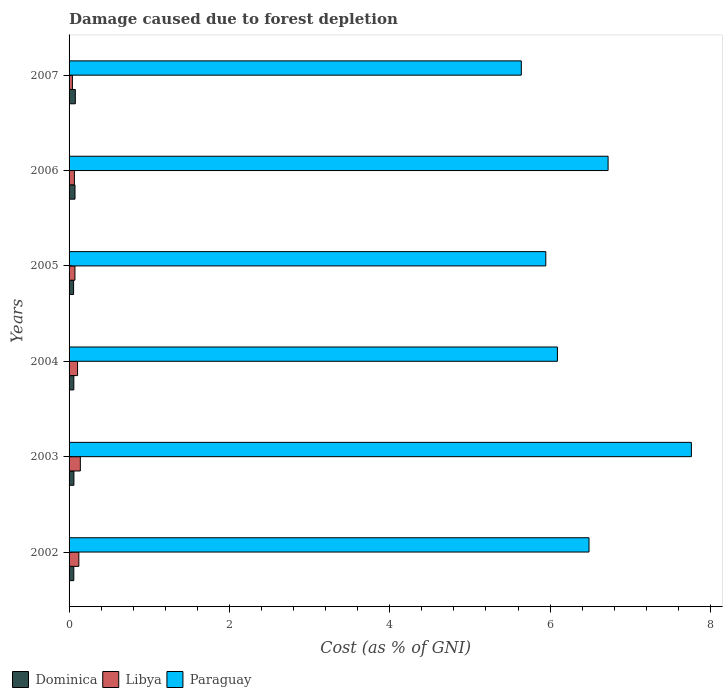How many different coloured bars are there?
Keep it short and to the point. 3. Are the number of bars on each tick of the Y-axis equal?
Ensure brevity in your answer.  Yes. What is the label of the 2nd group of bars from the top?
Give a very brief answer. 2006. In how many cases, is the number of bars for a given year not equal to the number of legend labels?
Your answer should be compact. 0. What is the cost of damage caused due to forest depletion in Paraguay in 2003?
Your answer should be very brief. 7.76. Across all years, what is the maximum cost of damage caused due to forest depletion in Paraguay?
Your answer should be compact. 7.76. Across all years, what is the minimum cost of damage caused due to forest depletion in Paraguay?
Your answer should be very brief. 5.64. In which year was the cost of damage caused due to forest depletion in Paraguay maximum?
Give a very brief answer. 2003. What is the total cost of damage caused due to forest depletion in Libya in the graph?
Provide a succinct answer. 0.55. What is the difference between the cost of damage caused due to forest depletion in Dominica in 2004 and that in 2007?
Offer a very short reply. -0.02. What is the difference between the cost of damage caused due to forest depletion in Libya in 2004 and the cost of damage caused due to forest depletion in Paraguay in 2006?
Provide a succinct answer. -6.62. What is the average cost of damage caused due to forest depletion in Dominica per year?
Your answer should be very brief. 0.06. In the year 2002, what is the difference between the cost of damage caused due to forest depletion in Libya and cost of damage caused due to forest depletion in Dominica?
Provide a succinct answer. 0.06. What is the ratio of the cost of damage caused due to forest depletion in Dominica in 2002 to that in 2004?
Offer a very short reply. 0.99. What is the difference between the highest and the second highest cost of damage caused due to forest depletion in Paraguay?
Give a very brief answer. 1.04. What is the difference between the highest and the lowest cost of damage caused due to forest depletion in Paraguay?
Offer a terse response. 2.12. In how many years, is the cost of damage caused due to forest depletion in Paraguay greater than the average cost of damage caused due to forest depletion in Paraguay taken over all years?
Make the answer very short. 3. Is the sum of the cost of damage caused due to forest depletion in Paraguay in 2002 and 2004 greater than the maximum cost of damage caused due to forest depletion in Dominica across all years?
Your answer should be compact. Yes. What does the 2nd bar from the top in 2003 represents?
Your answer should be compact. Libya. What does the 2nd bar from the bottom in 2002 represents?
Your response must be concise. Libya. How many bars are there?
Your response must be concise. 18. Are all the bars in the graph horizontal?
Make the answer very short. Yes. Are the values on the major ticks of X-axis written in scientific E-notation?
Give a very brief answer. No. Does the graph contain any zero values?
Provide a short and direct response. No. Does the graph contain grids?
Your answer should be very brief. No. Where does the legend appear in the graph?
Your answer should be compact. Bottom left. How many legend labels are there?
Offer a very short reply. 3. How are the legend labels stacked?
Your response must be concise. Horizontal. What is the title of the graph?
Your answer should be very brief. Damage caused due to forest depletion. Does "United Kingdom" appear as one of the legend labels in the graph?
Make the answer very short. No. What is the label or title of the X-axis?
Give a very brief answer. Cost (as % of GNI). What is the label or title of the Y-axis?
Your response must be concise. Years. What is the Cost (as % of GNI) in Dominica in 2002?
Make the answer very short. 0.06. What is the Cost (as % of GNI) in Libya in 2002?
Your response must be concise. 0.12. What is the Cost (as % of GNI) of Paraguay in 2002?
Your response must be concise. 6.49. What is the Cost (as % of GNI) in Dominica in 2003?
Offer a very short reply. 0.06. What is the Cost (as % of GNI) in Libya in 2003?
Offer a terse response. 0.14. What is the Cost (as % of GNI) of Paraguay in 2003?
Your response must be concise. 7.76. What is the Cost (as % of GNI) of Dominica in 2004?
Provide a succinct answer. 0.06. What is the Cost (as % of GNI) of Libya in 2004?
Provide a short and direct response. 0.11. What is the Cost (as % of GNI) of Paraguay in 2004?
Provide a succinct answer. 6.09. What is the Cost (as % of GNI) in Dominica in 2005?
Offer a terse response. 0.06. What is the Cost (as % of GNI) in Libya in 2005?
Provide a short and direct response. 0.07. What is the Cost (as % of GNI) of Paraguay in 2005?
Make the answer very short. 5.95. What is the Cost (as % of GNI) in Dominica in 2006?
Offer a very short reply. 0.07. What is the Cost (as % of GNI) of Libya in 2006?
Ensure brevity in your answer.  0.07. What is the Cost (as % of GNI) in Paraguay in 2006?
Your answer should be compact. 6.72. What is the Cost (as % of GNI) in Dominica in 2007?
Make the answer very short. 0.08. What is the Cost (as % of GNI) of Libya in 2007?
Offer a terse response. 0.04. What is the Cost (as % of GNI) of Paraguay in 2007?
Provide a succinct answer. 5.64. Across all years, what is the maximum Cost (as % of GNI) in Dominica?
Give a very brief answer. 0.08. Across all years, what is the maximum Cost (as % of GNI) in Libya?
Your response must be concise. 0.14. Across all years, what is the maximum Cost (as % of GNI) in Paraguay?
Give a very brief answer. 7.76. Across all years, what is the minimum Cost (as % of GNI) in Dominica?
Provide a short and direct response. 0.06. Across all years, what is the minimum Cost (as % of GNI) in Libya?
Your response must be concise. 0.04. Across all years, what is the minimum Cost (as % of GNI) in Paraguay?
Provide a succinct answer. 5.64. What is the total Cost (as % of GNI) in Dominica in the graph?
Keep it short and to the point. 0.39. What is the total Cost (as % of GNI) in Libya in the graph?
Ensure brevity in your answer.  0.55. What is the total Cost (as % of GNI) of Paraguay in the graph?
Make the answer very short. 38.65. What is the difference between the Cost (as % of GNI) in Dominica in 2002 and that in 2003?
Your response must be concise. -0. What is the difference between the Cost (as % of GNI) in Libya in 2002 and that in 2003?
Your answer should be compact. -0.02. What is the difference between the Cost (as % of GNI) of Paraguay in 2002 and that in 2003?
Give a very brief answer. -1.28. What is the difference between the Cost (as % of GNI) in Dominica in 2002 and that in 2004?
Your answer should be very brief. -0. What is the difference between the Cost (as % of GNI) of Libya in 2002 and that in 2004?
Your response must be concise. 0.02. What is the difference between the Cost (as % of GNI) in Paraguay in 2002 and that in 2004?
Ensure brevity in your answer.  0.39. What is the difference between the Cost (as % of GNI) in Dominica in 2002 and that in 2005?
Your answer should be very brief. 0. What is the difference between the Cost (as % of GNI) in Libya in 2002 and that in 2005?
Ensure brevity in your answer.  0.05. What is the difference between the Cost (as % of GNI) of Paraguay in 2002 and that in 2005?
Offer a very short reply. 0.54. What is the difference between the Cost (as % of GNI) in Dominica in 2002 and that in 2006?
Make the answer very short. -0.01. What is the difference between the Cost (as % of GNI) of Libya in 2002 and that in 2006?
Offer a very short reply. 0.06. What is the difference between the Cost (as % of GNI) of Paraguay in 2002 and that in 2006?
Your response must be concise. -0.24. What is the difference between the Cost (as % of GNI) of Dominica in 2002 and that in 2007?
Provide a short and direct response. -0.02. What is the difference between the Cost (as % of GNI) of Libya in 2002 and that in 2007?
Provide a succinct answer. 0.08. What is the difference between the Cost (as % of GNI) of Paraguay in 2002 and that in 2007?
Your answer should be very brief. 0.84. What is the difference between the Cost (as % of GNI) of Libya in 2003 and that in 2004?
Offer a very short reply. 0.03. What is the difference between the Cost (as % of GNI) of Paraguay in 2003 and that in 2004?
Your answer should be compact. 1.67. What is the difference between the Cost (as % of GNI) of Dominica in 2003 and that in 2005?
Offer a terse response. 0. What is the difference between the Cost (as % of GNI) of Libya in 2003 and that in 2005?
Your answer should be very brief. 0.07. What is the difference between the Cost (as % of GNI) in Paraguay in 2003 and that in 2005?
Your answer should be very brief. 1.82. What is the difference between the Cost (as % of GNI) of Dominica in 2003 and that in 2006?
Offer a very short reply. -0.01. What is the difference between the Cost (as % of GNI) in Libya in 2003 and that in 2006?
Provide a succinct answer. 0.07. What is the difference between the Cost (as % of GNI) in Paraguay in 2003 and that in 2006?
Ensure brevity in your answer.  1.04. What is the difference between the Cost (as % of GNI) in Dominica in 2003 and that in 2007?
Your answer should be very brief. -0.02. What is the difference between the Cost (as % of GNI) of Libya in 2003 and that in 2007?
Offer a very short reply. 0.1. What is the difference between the Cost (as % of GNI) of Paraguay in 2003 and that in 2007?
Give a very brief answer. 2.12. What is the difference between the Cost (as % of GNI) of Dominica in 2004 and that in 2005?
Give a very brief answer. 0. What is the difference between the Cost (as % of GNI) of Libya in 2004 and that in 2005?
Offer a very short reply. 0.03. What is the difference between the Cost (as % of GNI) of Paraguay in 2004 and that in 2005?
Your response must be concise. 0.15. What is the difference between the Cost (as % of GNI) of Dominica in 2004 and that in 2006?
Keep it short and to the point. -0.01. What is the difference between the Cost (as % of GNI) in Libya in 2004 and that in 2006?
Provide a short and direct response. 0.04. What is the difference between the Cost (as % of GNI) of Paraguay in 2004 and that in 2006?
Provide a succinct answer. -0.63. What is the difference between the Cost (as % of GNI) of Dominica in 2004 and that in 2007?
Your answer should be very brief. -0.02. What is the difference between the Cost (as % of GNI) of Libya in 2004 and that in 2007?
Your response must be concise. 0.06. What is the difference between the Cost (as % of GNI) in Paraguay in 2004 and that in 2007?
Your response must be concise. 0.45. What is the difference between the Cost (as % of GNI) of Dominica in 2005 and that in 2006?
Provide a short and direct response. -0.02. What is the difference between the Cost (as % of GNI) in Libya in 2005 and that in 2006?
Ensure brevity in your answer.  0.01. What is the difference between the Cost (as % of GNI) in Paraguay in 2005 and that in 2006?
Your response must be concise. -0.78. What is the difference between the Cost (as % of GNI) in Dominica in 2005 and that in 2007?
Make the answer very short. -0.02. What is the difference between the Cost (as % of GNI) in Libya in 2005 and that in 2007?
Your answer should be very brief. 0.03. What is the difference between the Cost (as % of GNI) in Paraguay in 2005 and that in 2007?
Ensure brevity in your answer.  0.31. What is the difference between the Cost (as % of GNI) in Dominica in 2006 and that in 2007?
Make the answer very short. -0. What is the difference between the Cost (as % of GNI) of Libya in 2006 and that in 2007?
Offer a terse response. 0.02. What is the difference between the Cost (as % of GNI) of Paraguay in 2006 and that in 2007?
Your answer should be compact. 1.08. What is the difference between the Cost (as % of GNI) of Dominica in 2002 and the Cost (as % of GNI) of Libya in 2003?
Keep it short and to the point. -0.08. What is the difference between the Cost (as % of GNI) in Dominica in 2002 and the Cost (as % of GNI) in Paraguay in 2003?
Keep it short and to the point. -7.7. What is the difference between the Cost (as % of GNI) of Libya in 2002 and the Cost (as % of GNI) of Paraguay in 2003?
Offer a very short reply. -7.64. What is the difference between the Cost (as % of GNI) of Dominica in 2002 and the Cost (as % of GNI) of Libya in 2004?
Offer a very short reply. -0.05. What is the difference between the Cost (as % of GNI) of Dominica in 2002 and the Cost (as % of GNI) of Paraguay in 2004?
Offer a very short reply. -6.03. What is the difference between the Cost (as % of GNI) in Libya in 2002 and the Cost (as % of GNI) in Paraguay in 2004?
Provide a succinct answer. -5.97. What is the difference between the Cost (as % of GNI) of Dominica in 2002 and the Cost (as % of GNI) of Libya in 2005?
Make the answer very short. -0.01. What is the difference between the Cost (as % of GNI) in Dominica in 2002 and the Cost (as % of GNI) in Paraguay in 2005?
Ensure brevity in your answer.  -5.89. What is the difference between the Cost (as % of GNI) in Libya in 2002 and the Cost (as % of GNI) in Paraguay in 2005?
Offer a terse response. -5.82. What is the difference between the Cost (as % of GNI) of Dominica in 2002 and the Cost (as % of GNI) of Libya in 2006?
Provide a short and direct response. -0.01. What is the difference between the Cost (as % of GNI) in Dominica in 2002 and the Cost (as % of GNI) in Paraguay in 2006?
Provide a succinct answer. -6.66. What is the difference between the Cost (as % of GNI) in Libya in 2002 and the Cost (as % of GNI) in Paraguay in 2006?
Keep it short and to the point. -6.6. What is the difference between the Cost (as % of GNI) in Dominica in 2002 and the Cost (as % of GNI) in Libya in 2007?
Provide a short and direct response. 0.02. What is the difference between the Cost (as % of GNI) of Dominica in 2002 and the Cost (as % of GNI) of Paraguay in 2007?
Your answer should be compact. -5.58. What is the difference between the Cost (as % of GNI) in Libya in 2002 and the Cost (as % of GNI) in Paraguay in 2007?
Provide a succinct answer. -5.52. What is the difference between the Cost (as % of GNI) in Dominica in 2003 and the Cost (as % of GNI) in Libya in 2004?
Your answer should be very brief. -0.05. What is the difference between the Cost (as % of GNI) in Dominica in 2003 and the Cost (as % of GNI) in Paraguay in 2004?
Provide a short and direct response. -6.03. What is the difference between the Cost (as % of GNI) in Libya in 2003 and the Cost (as % of GNI) in Paraguay in 2004?
Provide a short and direct response. -5.95. What is the difference between the Cost (as % of GNI) of Dominica in 2003 and the Cost (as % of GNI) of Libya in 2005?
Make the answer very short. -0.01. What is the difference between the Cost (as % of GNI) in Dominica in 2003 and the Cost (as % of GNI) in Paraguay in 2005?
Keep it short and to the point. -5.89. What is the difference between the Cost (as % of GNI) in Libya in 2003 and the Cost (as % of GNI) in Paraguay in 2005?
Give a very brief answer. -5.81. What is the difference between the Cost (as % of GNI) of Dominica in 2003 and the Cost (as % of GNI) of Libya in 2006?
Give a very brief answer. -0.01. What is the difference between the Cost (as % of GNI) of Dominica in 2003 and the Cost (as % of GNI) of Paraguay in 2006?
Provide a short and direct response. -6.66. What is the difference between the Cost (as % of GNI) in Libya in 2003 and the Cost (as % of GNI) in Paraguay in 2006?
Offer a very short reply. -6.58. What is the difference between the Cost (as % of GNI) of Dominica in 2003 and the Cost (as % of GNI) of Libya in 2007?
Make the answer very short. 0.02. What is the difference between the Cost (as % of GNI) in Dominica in 2003 and the Cost (as % of GNI) in Paraguay in 2007?
Make the answer very short. -5.58. What is the difference between the Cost (as % of GNI) of Libya in 2003 and the Cost (as % of GNI) of Paraguay in 2007?
Give a very brief answer. -5.5. What is the difference between the Cost (as % of GNI) in Dominica in 2004 and the Cost (as % of GNI) in Libya in 2005?
Provide a succinct answer. -0.01. What is the difference between the Cost (as % of GNI) in Dominica in 2004 and the Cost (as % of GNI) in Paraguay in 2005?
Give a very brief answer. -5.89. What is the difference between the Cost (as % of GNI) in Libya in 2004 and the Cost (as % of GNI) in Paraguay in 2005?
Offer a very short reply. -5.84. What is the difference between the Cost (as % of GNI) of Dominica in 2004 and the Cost (as % of GNI) of Libya in 2006?
Give a very brief answer. -0.01. What is the difference between the Cost (as % of GNI) of Dominica in 2004 and the Cost (as % of GNI) of Paraguay in 2006?
Give a very brief answer. -6.66. What is the difference between the Cost (as % of GNI) of Libya in 2004 and the Cost (as % of GNI) of Paraguay in 2006?
Offer a very short reply. -6.62. What is the difference between the Cost (as % of GNI) in Dominica in 2004 and the Cost (as % of GNI) in Libya in 2007?
Keep it short and to the point. 0.02. What is the difference between the Cost (as % of GNI) of Dominica in 2004 and the Cost (as % of GNI) of Paraguay in 2007?
Provide a succinct answer. -5.58. What is the difference between the Cost (as % of GNI) in Libya in 2004 and the Cost (as % of GNI) in Paraguay in 2007?
Keep it short and to the point. -5.54. What is the difference between the Cost (as % of GNI) of Dominica in 2005 and the Cost (as % of GNI) of Libya in 2006?
Make the answer very short. -0.01. What is the difference between the Cost (as % of GNI) in Dominica in 2005 and the Cost (as % of GNI) in Paraguay in 2006?
Your response must be concise. -6.67. What is the difference between the Cost (as % of GNI) of Libya in 2005 and the Cost (as % of GNI) of Paraguay in 2006?
Make the answer very short. -6.65. What is the difference between the Cost (as % of GNI) in Dominica in 2005 and the Cost (as % of GNI) in Libya in 2007?
Your answer should be very brief. 0.01. What is the difference between the Cost (as % of GNI) in Dominica in 2005 and the Cost (as % of GNI) in Paraguay in 2007?
Give a very brief answer. -5.58. What is the difference between the Cost (as % of GNI) of Libya in 2005 and the Cost (as % of GNI) of Paraguay in 2007?
Provide a succinct answer. -5.57. What is the difference between the Cost (as % of GNI) of Dominica in 2006 and the Cost (as % of GNI) of Libya in 2007?
Keep it short and to the point. 0.03. What is the difference between the Cost (as % of GNI) in Dominica in 2006 and the Cost (as % of GNI) in Paraguay in 2007?
Make the answer very short. -5.57. What is the difference between the Cost (as % of GNI) of Libya in 2006 and the Cost (as % of GNI) of Paraguay in 2007?
Keep it short and to the point. -5.57. What is the average Cost (as % of GNI) of Dominica per year?
Provide a short and direct response. 0.06. What is the average Cost (as % of GNI) in Libya per year?
Keep it short and to the point. 0.09. What is the average Cost (as % of GNI) in Paraguay per year?
Offer a very short reply. 6.44. In the year 2002, what is the difference between the Cost (as % of GNI) of Dominica and Cost (as % of GNI) of Libya?
Provide a short and direct response. -0.06. In the year 2002, what is the difference between the Cost (as % of GNI) in Dominica and Cost (as % of GNI) in Paraguay?
Keep it short and to the point. -6.43. In the year 2002, what is the difference between the Cost (as % of GNI) in Libya and Cost (as % of GNI) in Paraguay?
Provide a succinct answer. -6.36. In the year 2003, what is the difference between the Cost (as % of GNI) of Dominica and Cost (as % of GNI) of Libya?
Your response must be concise. -0.08. In the year 2003, what is the difference between the Cost (as % of GNI) of Dominica and Cost (as % of GNI) of Paraguay?
Offer a terse response. -7.7. In the year 2003, what is the difference between the Cost (as % of GNI) of Libya and Cost (as % of GNI) of Paraguay?
Make the answer very short. -7.62. In the year 2004, what is the difference between the Cost (as % of GNI) in Dominica and Cost (as % of GNI) in Libya?
Your response must be concise. -0.05. In the year 2004, what is the difference between the Cost (as % of GNI) of Dominica and Cost (as % of GNI) of Paraguay?
Offer a very short reply. -6.03. In the year 2004, what is the difference between the Cost (as % of GNI) of Libya and Cost (as % of GNI) of Paraguay?
Make the answer very short. -5.99. In the year 2005, what is the difference between the Cost (as % of GNI) in Dominica and Cost (as % of GNI) in Libya?
Provide a short and direct response. -0.02. In the year 2005, what is the difference between the Cost (as % of GNI) in Dominica and Cost (as % of GNI) in Paraguay?
Your response must be concise. -5.89. In the year 2005, what is the difference between the Cost (as % of GNI) in Libya and Cost (as % of GNI) in Paraguay?
Your answer should be compact. -5.87. In the year 2006, what is the difference between the Cost (as % of GNI) in Dominica and Cost (as % of GNI) in Libya?
Make the answer very short. 0.01. In the year 2006, what is the difference between the Cost (as % of GNI) in Dominica and Cost (as % of GNI) in Paraguay?
Give a very brief answer. -6.65. In the year 2006, what is the difference between the Cost (as % of GNI) of Libya and Cost (as % of GNI) of Paraguay?
Keep it short and to the point. -6.66. In the year 2007, what is the difference between the Cost (as % of GNI) in Dominica and Cost (as % of GNI) in Libya?
Your response must be concise. 0.04. In the year 2007, what is the difference between the Cost (as % of GNI) of Dominica and Cost (as % of GNI) of Paraguay?
Offer a very short reply. -5.56. In the year 2007, what is the difference between the Cost (as % of GNI) in Libya and Cost (as % of GNI) in Paraguay?
Your response must be concise. -5.6. What is the ratio of the Cost (as % of GNI) of Dominica in 2002 to that in 2003?
Make the answer very short. 0.98. What is the ratio of the Cost (as % of GNI) of Libya in 2002 to that in 2003?
Provide a short and direct response. 0.87. What is the ratio of the Cost (as % of GNI) of Paraguay in 2002 to that in 2003?
Provide a short and direct response. 0.84. What is the ratio of the Cost (as % of GNI) of Libya in 2002 to that in 2004?
Offer a terse response. 1.15. What is the ratio of the Cost (as % of GNI) of Paraguay in 2002 to that in 2004?
Your answer should be very brief. 1.06. What is the ratio of the Cost (as % of GNI) of Dominica in 2002 to that in 2005?
Provide a short and direct response. 1.05. What is the ratio of the Cost (as % of GNI) in Libya in 2002 to that in 2005?
Your answer should be compact. 1.66. What is the ratio of the Cost (as % of GNI) of Paraguay in 2002 to that in 2005?
Give a very brief answer. 1.09. What is the ratio of the Cost (as % of GNI) of Dominica in 2002 to that in 2006?
Your answer should be very brief. 0.8. What is the ratio of the Cost (as % of GNI) of Libya in 2002 to that in 2006?
Offer a terse response. 1.84. What is the ratio of the Cost (as % of GNI) of Paraguay in 2002 to that in 2006?
Give a very brief answer. 0.96. What is the ratio of the Cost (as % of GNI) in Dominica in 2002 to that in 2007?
Offer a very short reply. 0.76. What is the ratio of the Cost (as % of GNI) of Libya in 2002 to that in 2007?
Give a very brief answer. 2.93. What is the ratio of the Cost (as % of GNI) of Paraguay in 2002 to that in 2007?
Provide a short and direct response. 1.15. What is the ratio of the Cost (as % of GNI) in Dominica in 2003 to that in 2004?
Offer a terse response. 1.02. What is the ratio of the Cost (as % of GNI) in Libya in 2003 to that in 2004?
Keep it short and to the point. 1.33. What is the ratio of the Cost (as % of GNI) of Paraguay in 2003 to that in 2004?
Provide a short and direct response. 1.27. What is the ratio of the Cost (as % of GNI) of Dominica in 2003 to that in 2005?
Your response must be concise. 1.07. What is the ratio of the Cost (as % of GNI) of Libya in 2003 to that in 2005?
Ensure brevity in your answer.  1.92. What is the ratio of the Cost (as % of GNI) in Paraguay in 2003 to that in 2005?
Ensure brevity in your answer.  1.31. What is the ratio of the Cost (as % of GNI) of Dominica in 2003 to that in 2006?
Your response must be concise. 0.82. What is the ratio of the Cost (as % of GNI) in Libya in 2003 to that in 2006?
Provide a succinct answer. 2.12. What is the ratio of the Cost (as % of GNI) in Paraguay in 2003 to that in 2006?
Make the answer very short. 1.15. What is the ratio of the Cost (as % of GNI) in Dominica in 2003 to that in 2007?
Keep it short and to the point. 0.77. What is the ratio of the Cost (as % of GNI) in Libya in 2003 to that in 2007?
Make the answer very short. 3.38. What is the ratio of the Cost (as % of GNI) in Paraguay in 2003 to that in 2007?
Your response must be concise. 1.38. What is the ratio of the Cost (as % of GNI) of Dominica in 2004 to that in 2005?
Your response must be concise. 1.05. What is the ratio of the Cost (as % of GNI) of Libya in 2004 to that in 2005?
Give a very brief answer. 1.45. What is the ratio of the Cost (as % of GNI) of Paraguay in 2004 to that in 2005?
Your answer should be compact. 1.02. What is the ratio of the Cost (as % of GNI) of Dominica in 2004 to that in 2006?
Give a very brief answer. 0.8. What is the ratio of the Cost (as % of GNI) in Libya in 2004 to that in 2006?
Keep it short and to the point. 1.6. What is the ratio of the Cost (as % of GNI) in Paraguay in 2004 to that in 2006?
Offer a terse response. 0.91. What is the ratio of the Cost (as % of GNI) of Dominica in 2004 to that in 2007?
Provide a short and direct response. 0.76. What is the ratio of the Cost (as % of GNI) in Libya in 2004 to that in 2007?
Make the answer very short. 2.54. What is the ratio of the Cost (as % of GNI) in Paraguay in 2004 to that in 2007?
Offer a terse response. 1.08. What is the ratio of the Cost (as % of GNI) in Dominica in 2005 to that in 2006?
Make the answer very short. 0.76. What is the ratio of the Cost (as % of GNI) in Libya in 2005 to that in 2006?
Offer a terse response. 1.1. What is the ratio of the Cost (as % of GNI) of Paraguay in 2005 to that in 2006?
Your answer should be very brief. 0.88. What is the ratio of the Cost (as % of GNI) in Dominica in 2005 to that in 2007?
Provide a short and direct response. 0.72. What is the ratio of the Cost (as % of GNI) of Libya in 2005 to that in 2007?
Make the answer very short. 1.76. What is the ratio of the Cost (as % of GNI) in Paraguay in 2005 to that in 2007?
Provide a short and direct response. 1.05. What is the ratio of the Cost (as % of GNI) in Dominica in 2006 to that in 2007?
Keep it short and to the point. 0.95. What is the ratio of the Cost (as % of GNI) in Libya in 2006 to that in 2007?
Provide a short and direct response. 1.59. What is the ratio of the Cost (as % of GNI) of Paraguay in 2006 to that in 2007?
Give a very brief answer. 1.19. What is the difference between the highest and the second highest Cost (as % of GNI) of Dominica?
Your answer should be compact. 0. What is the difference between the highest and the second highest Cost (as % of GNI) in Libya?
Keep it short and to the point. 0.02. What is the difference between the highest and the second highest Cost (as % of GNI) of Paraguay?
Your answer should be compact. 1.04. What is the difference between the highest and the lowest Cost (as % of GNI) of Dominica?
Ensure brevity in your answer.  0.02. What is the difference between the highest and the lowest Cost (as % of GNI) of Libya?
Your response must be concise. 0.1. What is the difference between the highest and the lowest Cost (as % of GNI) in Paraguay?
Your answer should be very brief. 2.12. 